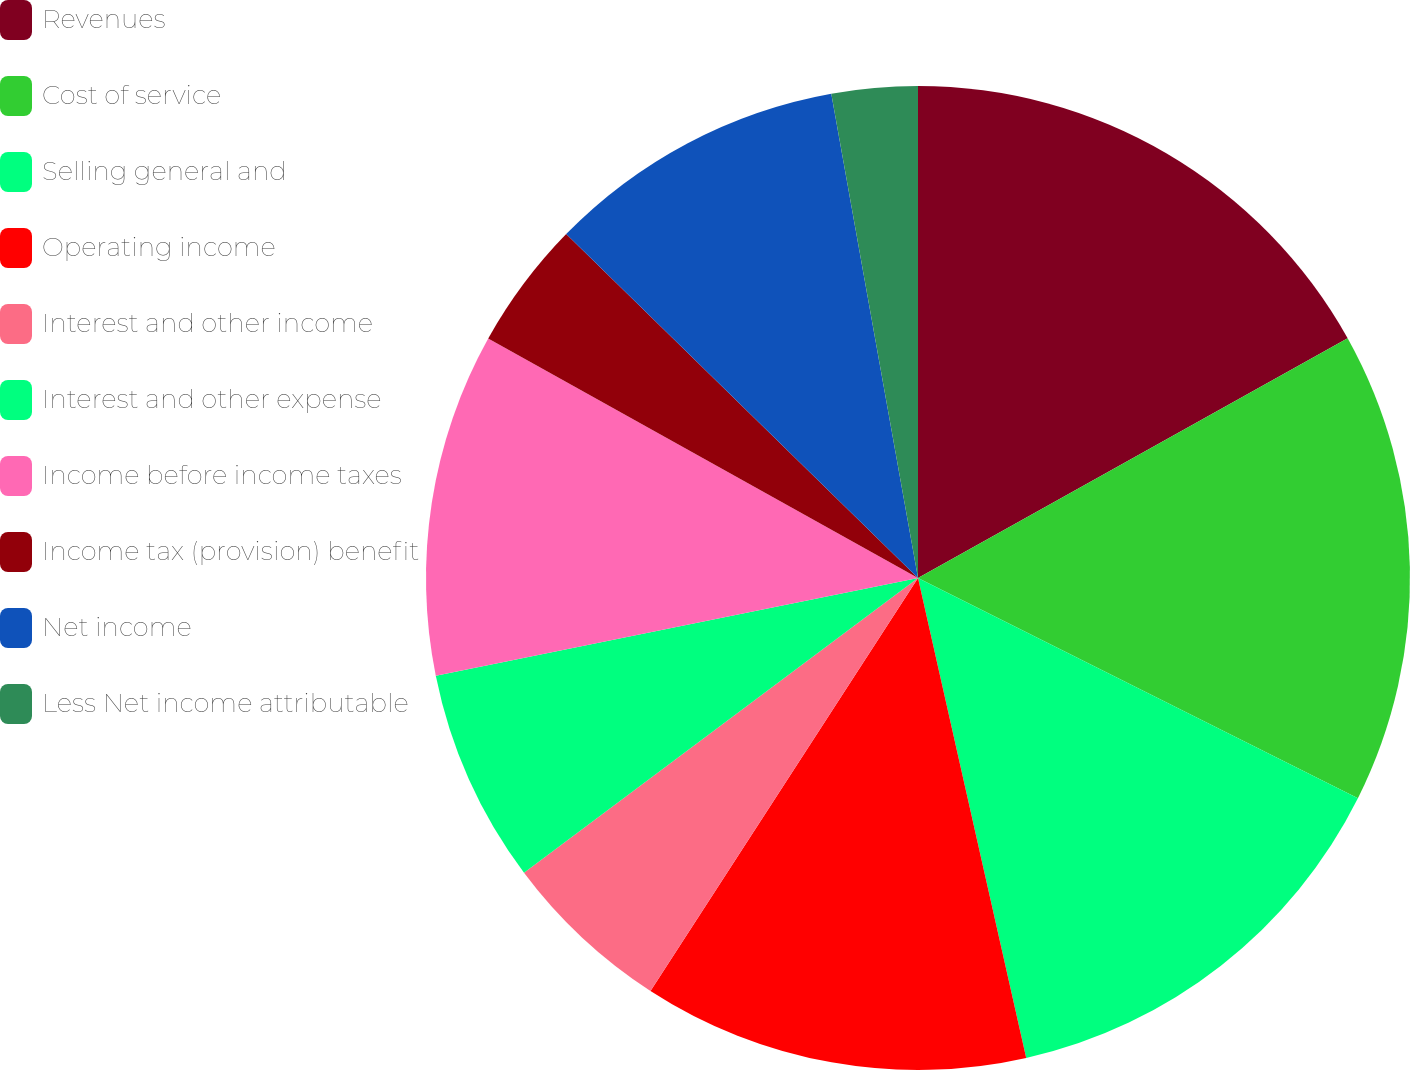Convert chart. <chart><loc_0><loc_0><loc_500><loc_500><pie_chart><fcel>Revenues<fcel>Cost of service<fcel>Selling general and<fcel>Operating income<fcel>Interest and other income<fcel>Interest and other expense<fcel>Income before income taxes<fcel>Income tax (provision) benefit<fcel>Net income<fcel>Less Net income attributable<nl><fcel>16.9%<fcel>15.49%<fcel>14.08%<fcel>12.68%<fcel>5.63%<fcel>7.04%<fcel>11.27%<fcel>4.23%<fcel>9.86%<fcel>2.82%<nl></chart> 